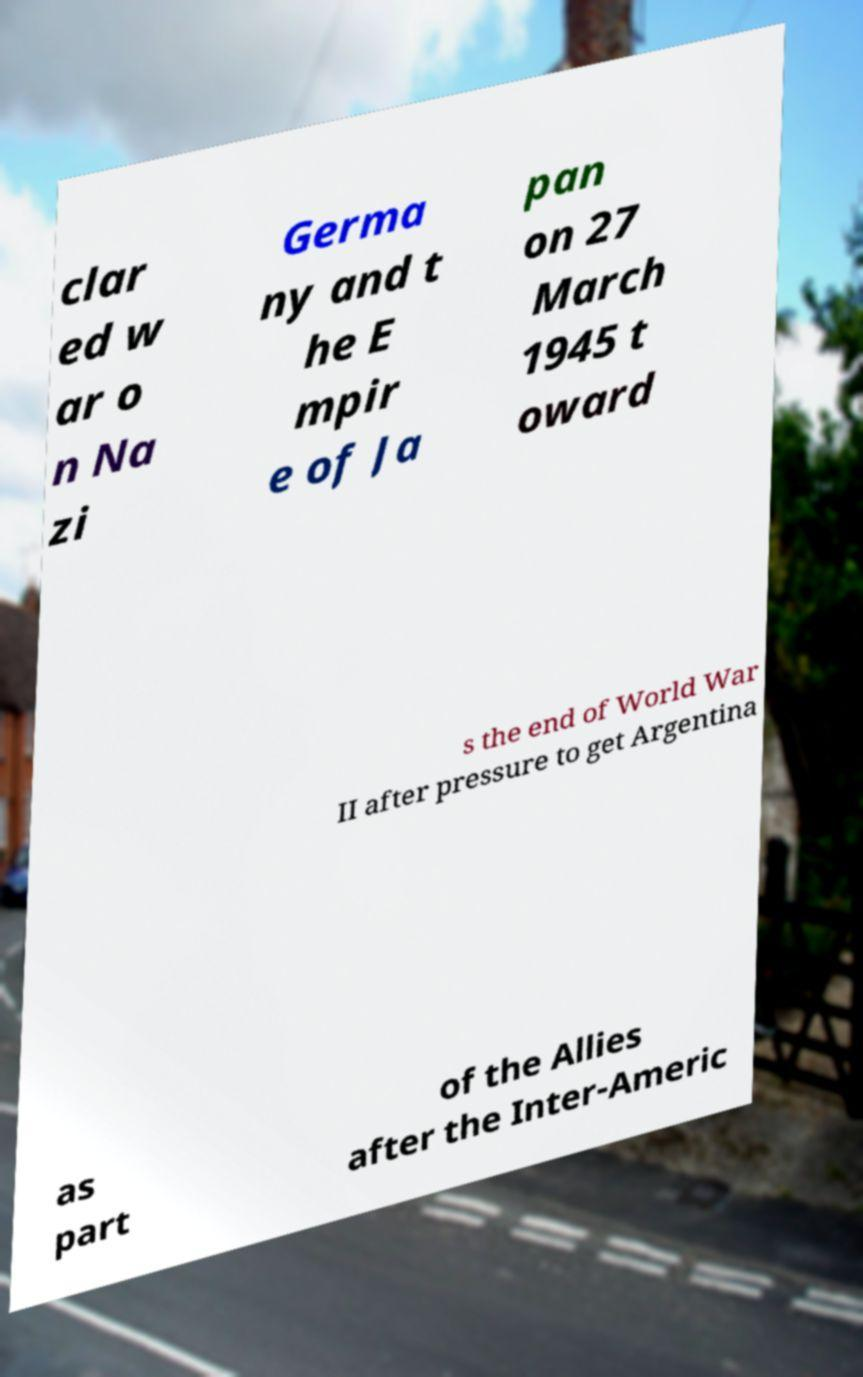Please identify and transcribe the text found in this image. clar ed w ar o n Na zi Germa ny and t he E mpir e of Ja pan on 27 March 1945 t oward s the end of World War II after pressure to get Argentina as part of the Allies after the Inter-Americ 